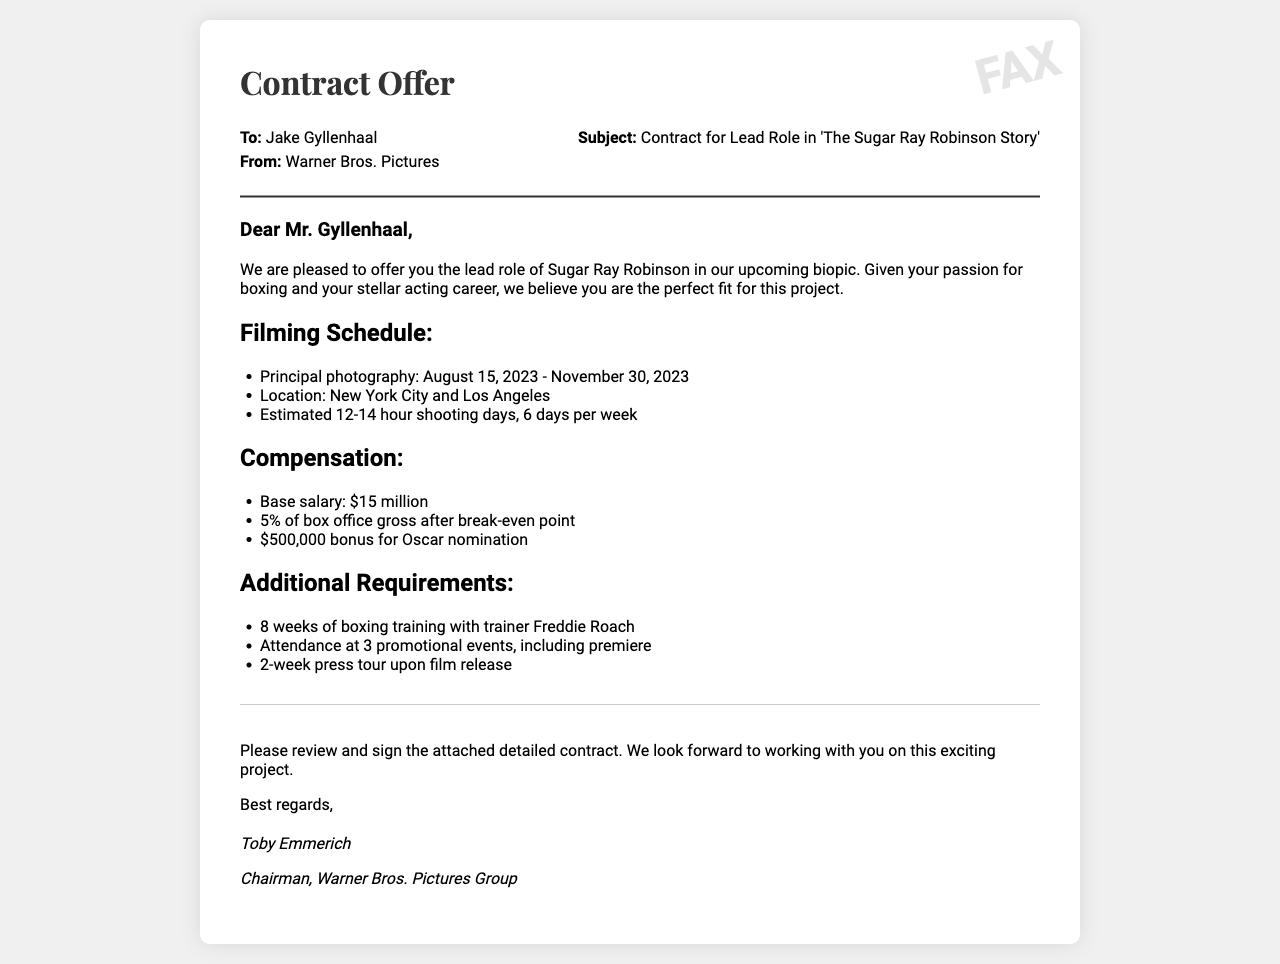What is the lead role being offered? The document specifies that the lead role is for Sugar Ray Robinson in the biopic.
Answer: Sugar Ray Robinson What is the start date of principal photography? The document states the principal photography starts on August 15, 2023.
Answer: August 15, 2023 What is the base salary for the role? According to the document, the base salary offered is $15 million.
Answer: $15 million Which cities will the filming take place in? The document mentions that filming will occur in New York City and Los Angeles.
Answer: New York City and Los Angeles How many hours are estimated for shooting days? The document estimates 12-14 hour shooting days.
Answer: 12-14 hours What bonus is offered for an Oscar nomination? The document indicates a bonus of $500,000 for an Oscar nomination.
Answer: $500,000 Who is the trainer for the boxing training? The document states that Freddie Roach will be the trainer for the boxing training.
Answer: Freddie Roach How many promotional events must the actor attend? The document specifies attendance at 3 promotional events.
Answer: 3 What position does Toby Emmerich hold? The document identifies Toby Emmerich as Chairman of Warner Bros. Pictures Group.
Answer: Chairman 